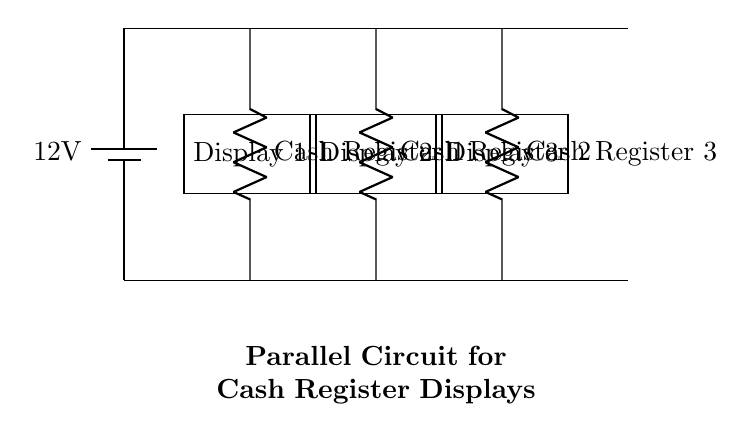What is the voltage of this circuit? The voltage is 12 volts, indicated by the battery symbol at the top of the circuit diagram. The battery provides a potential difference of 12 volts for the entire circuit.
Answer: 12 volts How many cash registers are connected in this circuit? There are three cash registers shown in the circuit, each represented by a resistor symbol labeled as Cash Register 1, Cash Register 2, and Cash Register 3.
Answer: Three What type of circuit is this? This is a parallel circuit, as all components (cash registers) are connected along different paths between the same two voltage points, allowing them to operate independently.
Answer: Parallel What is the purpose of the display screens in this circuit? The display screens serve to show transaction information for each cash register, as indicated by their labels Display 1, Display 2, and Display 3, placed directly above each register.
Answer: To show transaction information How does the current behave in this parallel circuit? In a parallel circuit, the total current is divided among the branches; each cash register gets the same voltage (12 volts), but the current through each branch could vary depending on the resistance of each register.
Answer: Divided What would happen to the other cash registers if one fails? If one cash register fails or is disconnected, the other cash registers would continue to function because each branch operates independently in a parallel circuit.
Answer: They would continue to function 